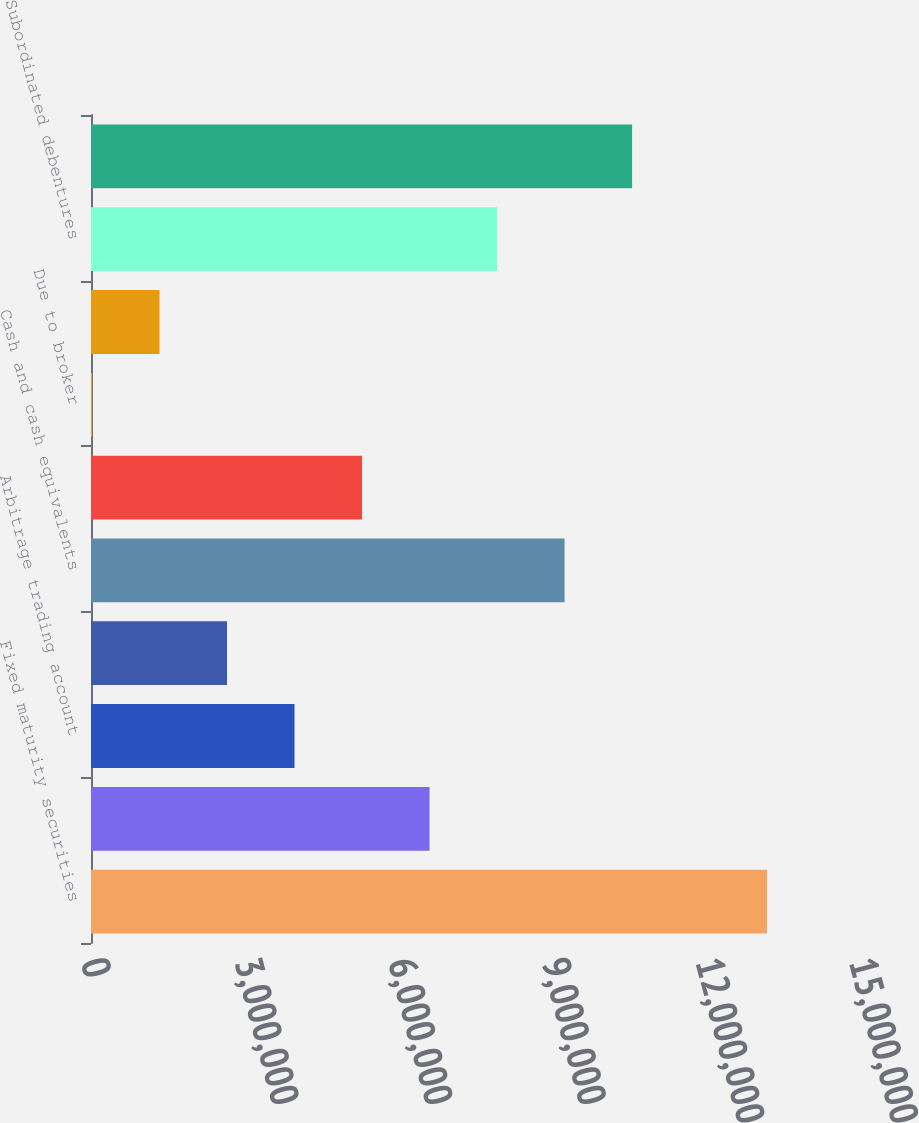<chart> <loc_0><loc_0><loc_500><loc_500><bar_chart><fcel>Fixed maturity securities<fcel>Equity securities available<fcel>Arbitrage trading account<fcel>Loans receivable<fcel>Cash and cash equivalents<fcel>Trading accounts receivable<fcel>Due to broker<fcel>Trading account securities<fcel>Subordinated debentures<fcel>Senior notes and other debt<nl><fcel>1.32048e+07<fcel>6.61212e+06<fcel>3.97504e+06<fcel>2.6565e+06<fcel>9.24919e+06<fcel>5.29358e+06<fcel>19416<fcel>1.33796e+06<fcel>7.93065e+06<fcel>1.05677e+07<nl></chart> 